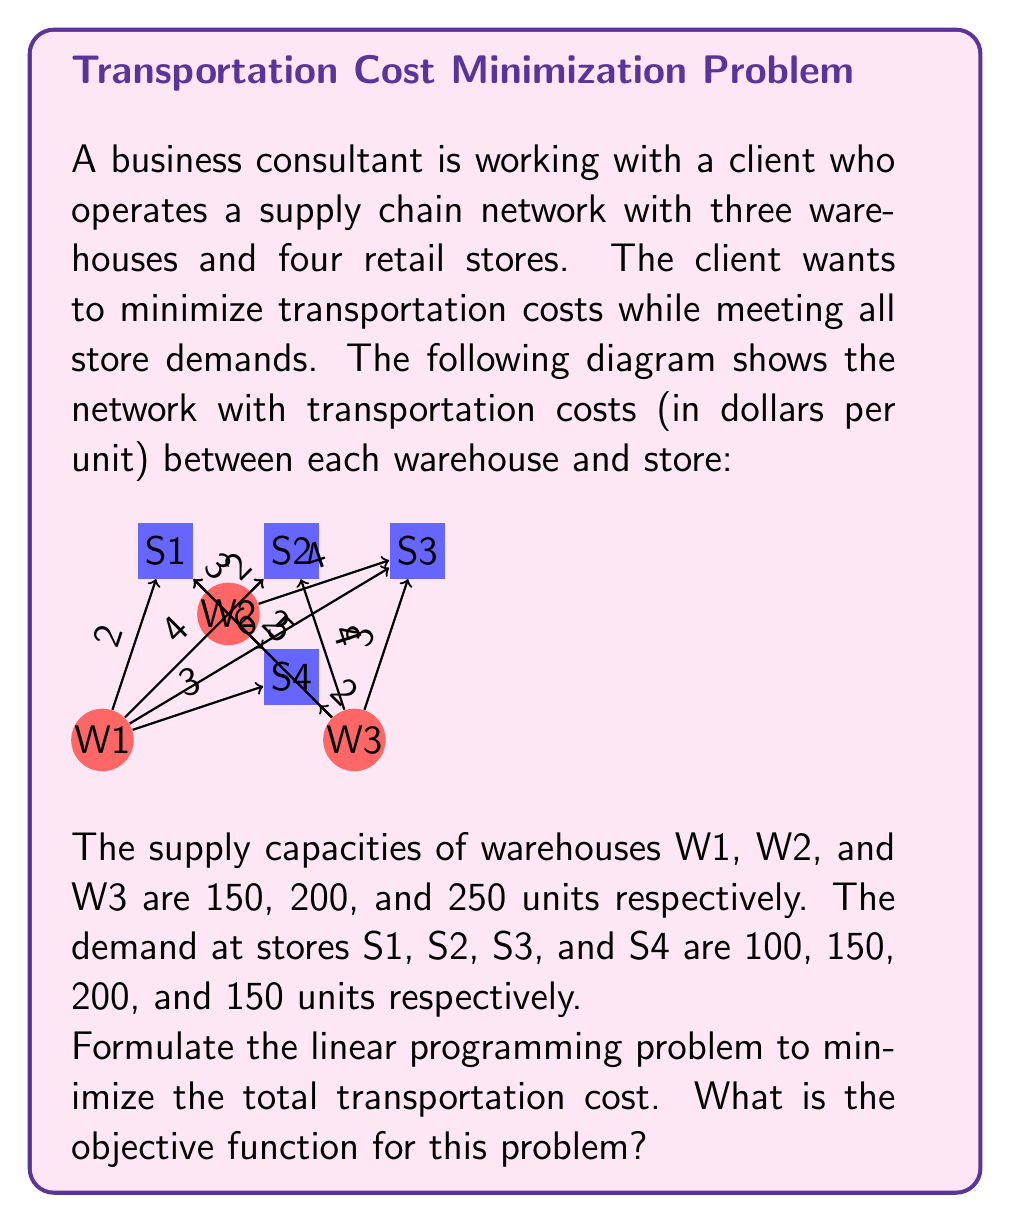Help me with this question. To formulate the linear programming problem, we need to define the decision variables and set up the objective function and constraints.

Step 1: Define decision variables
Let $x_{ij}$ represent the number of units shipped from warehouse i to store j.
i = 1, 2, 3 (warehouses)
j = 1, 2, 3, 4 (stores)

Step 2: Set up the objective function
The objective is to minimize the total transportation cost. We multiply each decision variable by its corresponding cost and sum them all up:

$$\text{Minimize } Z = 2x_{11} + 4x_{12} + 6x_{13} + 3x_{14} + 3x_{21} + 2x_{22} + 4x_{23} + 2x_{24} + 5x_{31} + 4x_{32} + 3x_{33} + 2x_{34}$$

Step 3: Set up the constraints
Supply constraints (for each warehouse):
$$x_{11} + x_{12} + x_{13} + x_{14} \leq 150$$
$$x_{21} + x_{22} + x_{23} + x_{24} \leq 200$$
$$x_{31} + x_{32} + x_{33} + x_{34} \leq 250$$

Demand constraints (for each store):
$$x_{11} + x_{21} + x_{31} = 100$$
$$x_{12} + x_{22} + x_{32} = 150$$
$$x_{13} + x_{23} + x_{33} = 200$$
$$x_{14} + x_{24} + x_{34} = 150$$

Non-negativity constraints:
$$x_{ij} \geq 0 \text{ for all } i \text{ and } j$$

The objective function is the mathematical expression we want to minimize, which represents the total transportation cost in this case.
Answer: $$\text{Minimize } Z = 2x_{11} + 4x_{12} + 6x_{13} + 3x_{14} + 3x_{21} + 2x_{22} + 4x_{23} + 2x_{24} + 5x_{31} + 4x_{32} + 3x_{33} + 2x_{34}$$ 